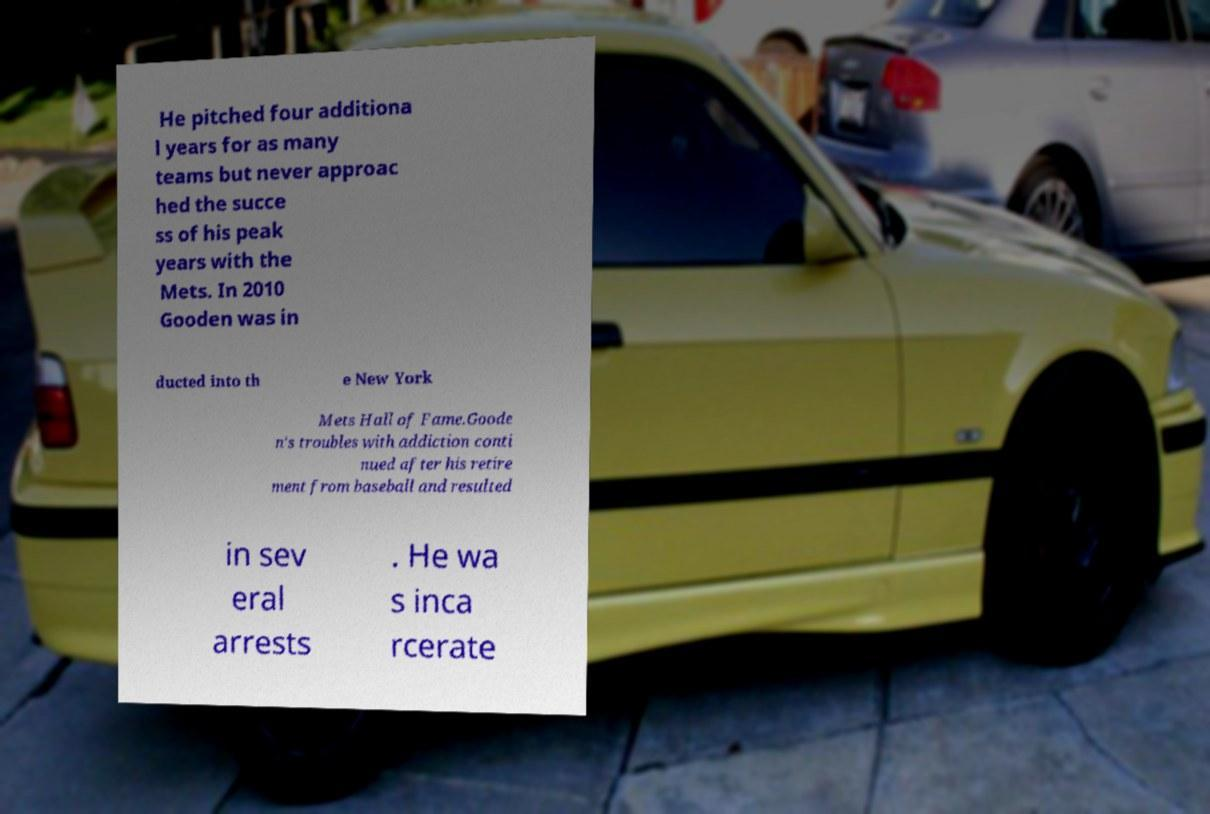Could you extract and type out the text from this image? He pitched four additiona l years for as many teams but never approac hed the succe ss of his peak years with the Mets. In 2010 Gooden was in ducted into th e New York Mets Hall of Fame.Goode n's troubles with addiction conti nued after his retire ment from baseball and resulted in sev eral arrests . He wa s inca rcerate 